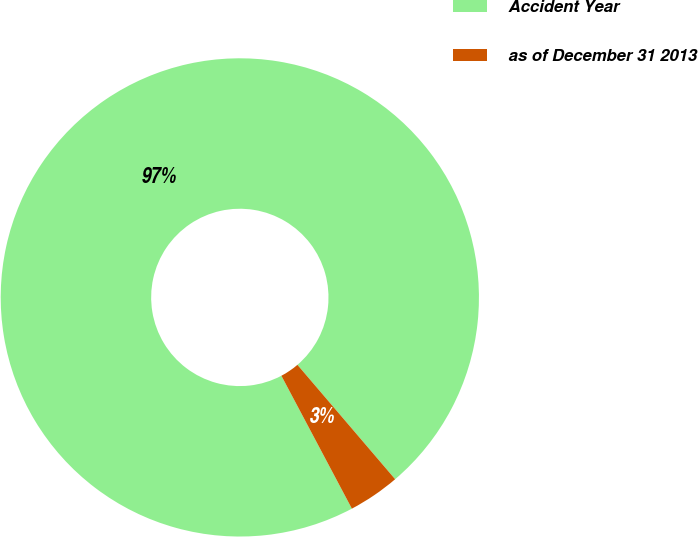Convert chart to OTSL. <chart><loc_0><loc_0><loc_500><loc_500><pie_chart><fcel>Accident Year<fcel>as of December 31 2013<nl><fcel>96.51%<fcel>3.49%<nl></chart> 